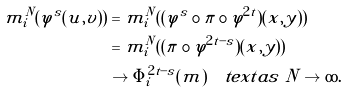<formula> <loc_0><loc_0><loc_500><loc_500>m _ { i } ^ { N } ( \varphi ^ { s } ( u , v ) ) & = m _ { i } ^ { N } ( ( \varphi ^ { s } \circ \pi \circ \varphi ^ { 2 t } ) ( x , y ) ) \\ & = m _ { i } ^ { N } ( ( \pi \circ \varphi ^ { 2 t - s } ) ( x , y ) ) \\ & \to \Phi _ { i } ^ { 2 t - s } ( m ) \quad t e x t { a s } \ N \to \infty .</formula> 